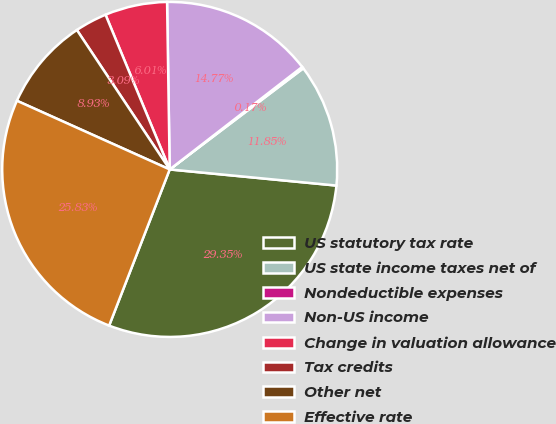Convert chart. <chart><loc_0><loc_0><loc_500><loc_500><pie_chart><fcel>US statutory tax rate<fcel>US state income taxes net of<fcel>Nondeductible expenses<fcel>Non-US income<fcel>Change in valuation allowance<fcel>Tax credits<fcel>Other net<fcel>Effective rate<nl><fcel>29.36%<fcel>11.85%<fcel>0.17%<fcel>14.77%<fcel>6.01%<fcel>3.09%<fcel>8.93%<fcel>25.84%<nl></chart> 